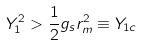<formula> <loc_0><loc_0><loc_500><loc_500>Y _ { 1 } ^ { 2 } > \frac { 1 } { 2 } g _ { s } r _ { m } ^ { 2 } \equiv Y _ { 1 c }</formula> 